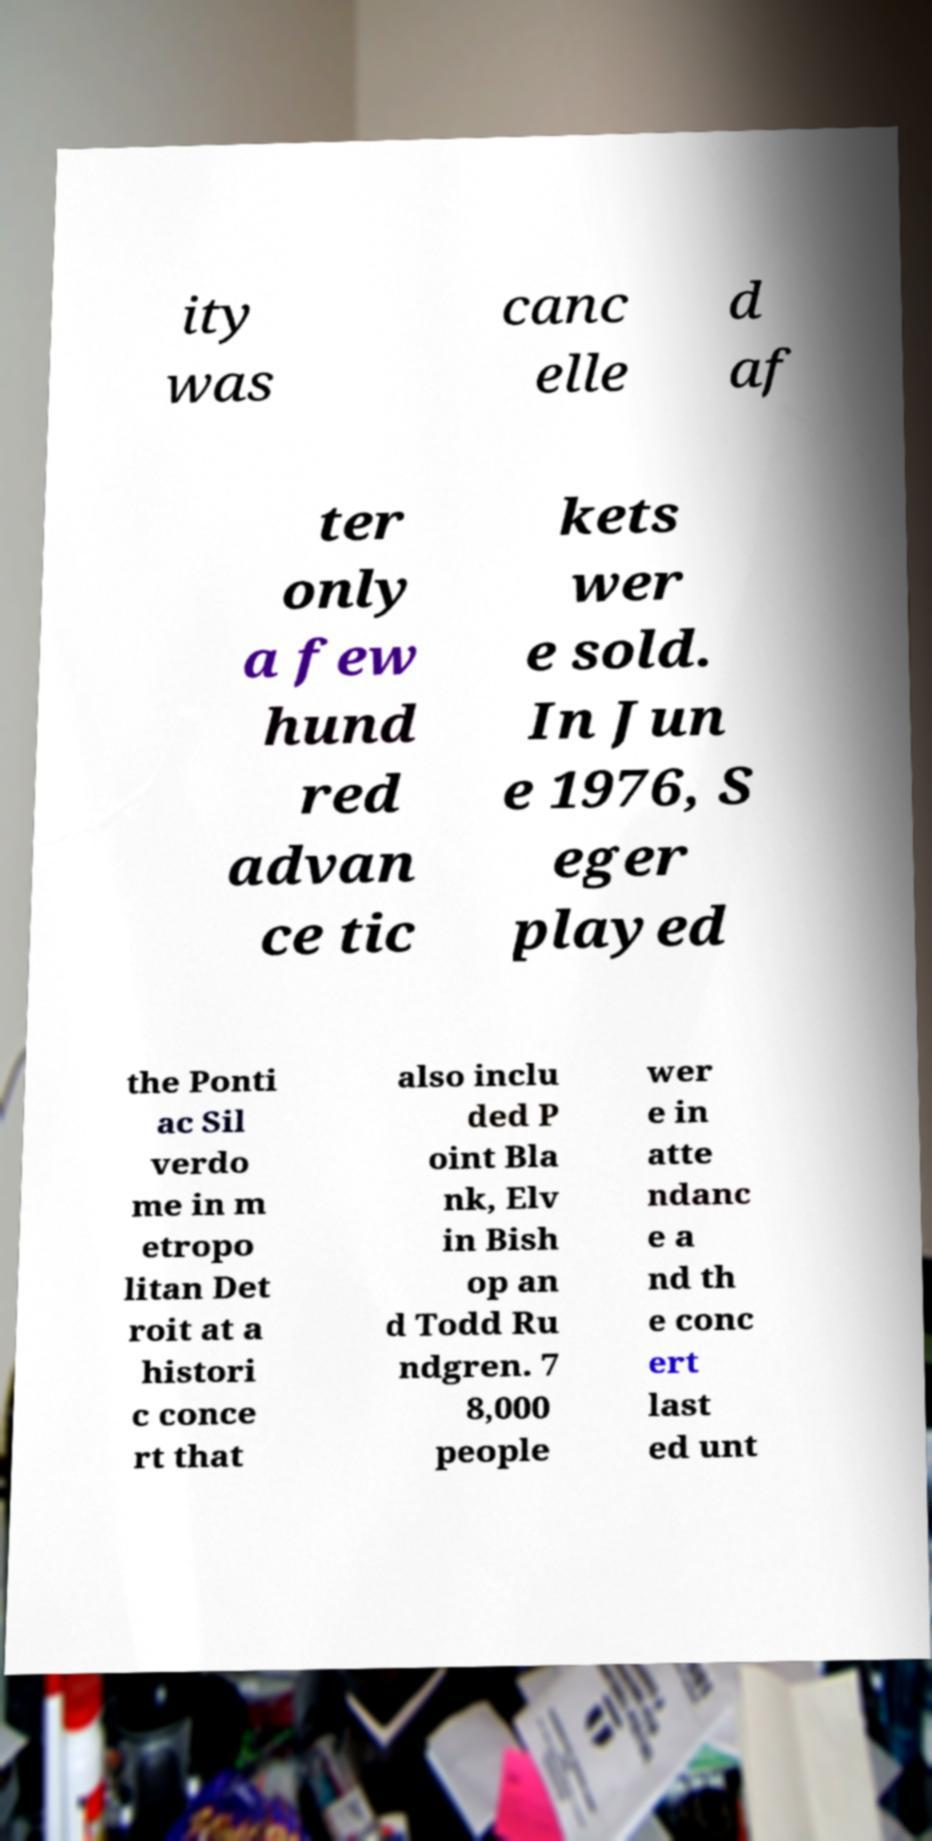For documentation purposes, I need the text within this image transcribed. Could you provide that? ity was canc elle d af ter only a few hund red advan ce tic kets wer e sold. In Jun e 1976, S eger played the Ponti ac Sil verdo me in m etropo litan Det roit at a histori c conce rt that also inclu ded P oint Bla nk, Elv in Bish op an d Todd Ru ndgren. 7 8,000 people wer e in atte ndanc e a nd th e conc ert last ed unt 